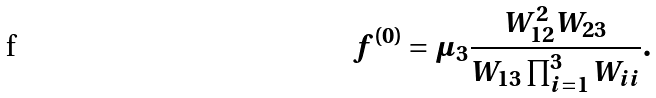<formula> <loc_0><loc_0><loc_500><loc_500>f ^ { ( 0 ) } = \mu _ { 3 } \frac { W _ { 1 2 } ^ { 2 } W _ { 2 3 } } { W _ { 1 3 } \prod _ { i = 1 } ^ { 3 } W _ { i i } } .</formula> 